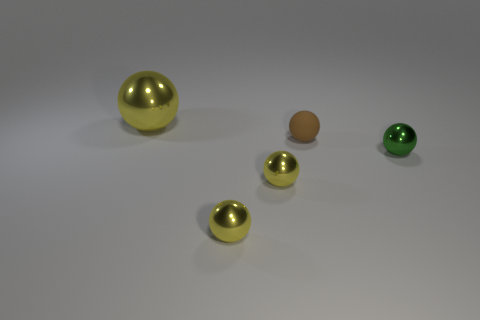Add 4 small brown spheres. How many objects exist? 9 Subtract all tiny rubber spheres. How many spheres are left? 4 Subtract all cyan blocks. How many yellow spheres are left? 3 Subtract 4 spheres. How many spheres are left? 1 Subtract all green spheres. How many spheres are left? 4 Subtract all yellow spheres. Subtract all brown cylinders. How many spheres are left? 2 Subtract all tiny blue things. Subtract all tiny brown balls. How many objects are left? 4 Add 2 brown rubber objects. How many brown rubber objects are left? 3 Add 2 large yellow metallic balls. How many large yellow metallic balls exist? 3 Subtract 0 green cylinders. How many objects are left? 5 